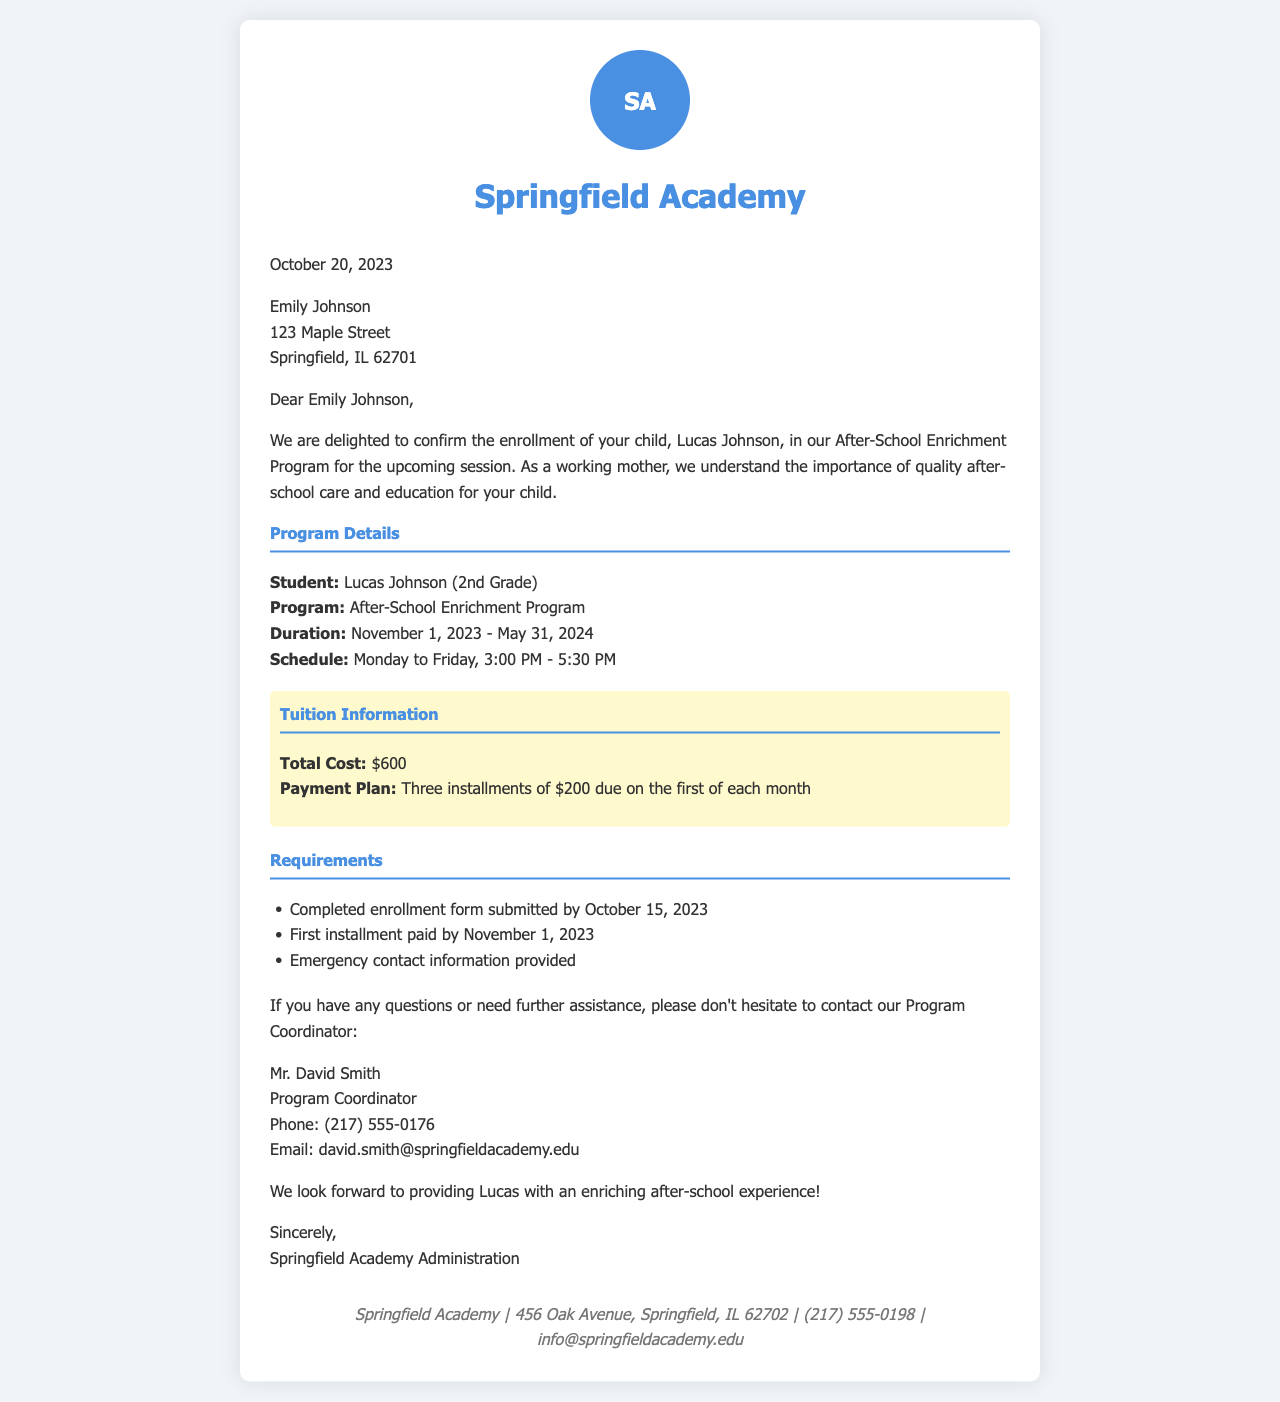What is the name of the student? The student's name is mentioned in the program details section of the document.
Answer: Lucas Johnson What is the duration of the After-School Enrichment Program? The duration is specified in the program details section.
Answer: November 1, 2023 - May 31, 2024 What is the total cost of the program? The total cost is highlighted in the tuition information section of the document.
Answer: $600 What is the payment due date for the first installment? This date is given in the tuition information section, indicating when the first installment should be paid.
Answer: November 1, 2023 Who is the Program Coordinator? The Program Coordinator's name is provided in the contact information section of the document.
Answer: Mr. David Smith What time does the program start each day? The start time is listed in the schedule within the program details section.
Answer: 3:00 PM What is one requirement for the program enrollment? One of the requirements is mentioned in the requirements section, specifying what needs to be completed before enrollment.
Answer: Completed enrollment form submitted by October 15, 2023 What is the scheduled ending time for the program? The ending time is provided in the schedule within the program details section.
Answer: 5:30 PM How many installments are required for payment? This information is noted in the tuition information section, indicating the payment structure.
Answer: Three installments 